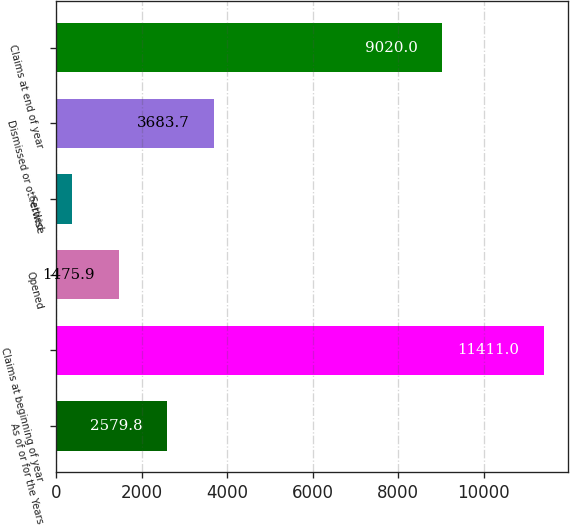<chart> <loc_0><loc_0><loc_500><loc_500><bar_chart><fcel>As of or for the Years<fcel>Claims at beginning of year<fcel>Opened<fcel>Settled<fcel>Dismissed or otherwise<fcel>Claims at end of year<nl><fcel>2579.8<fcel>11411<fcel>1475.9<fcel>372<fcel>3683.7<fcel>9020<nl></chart> 